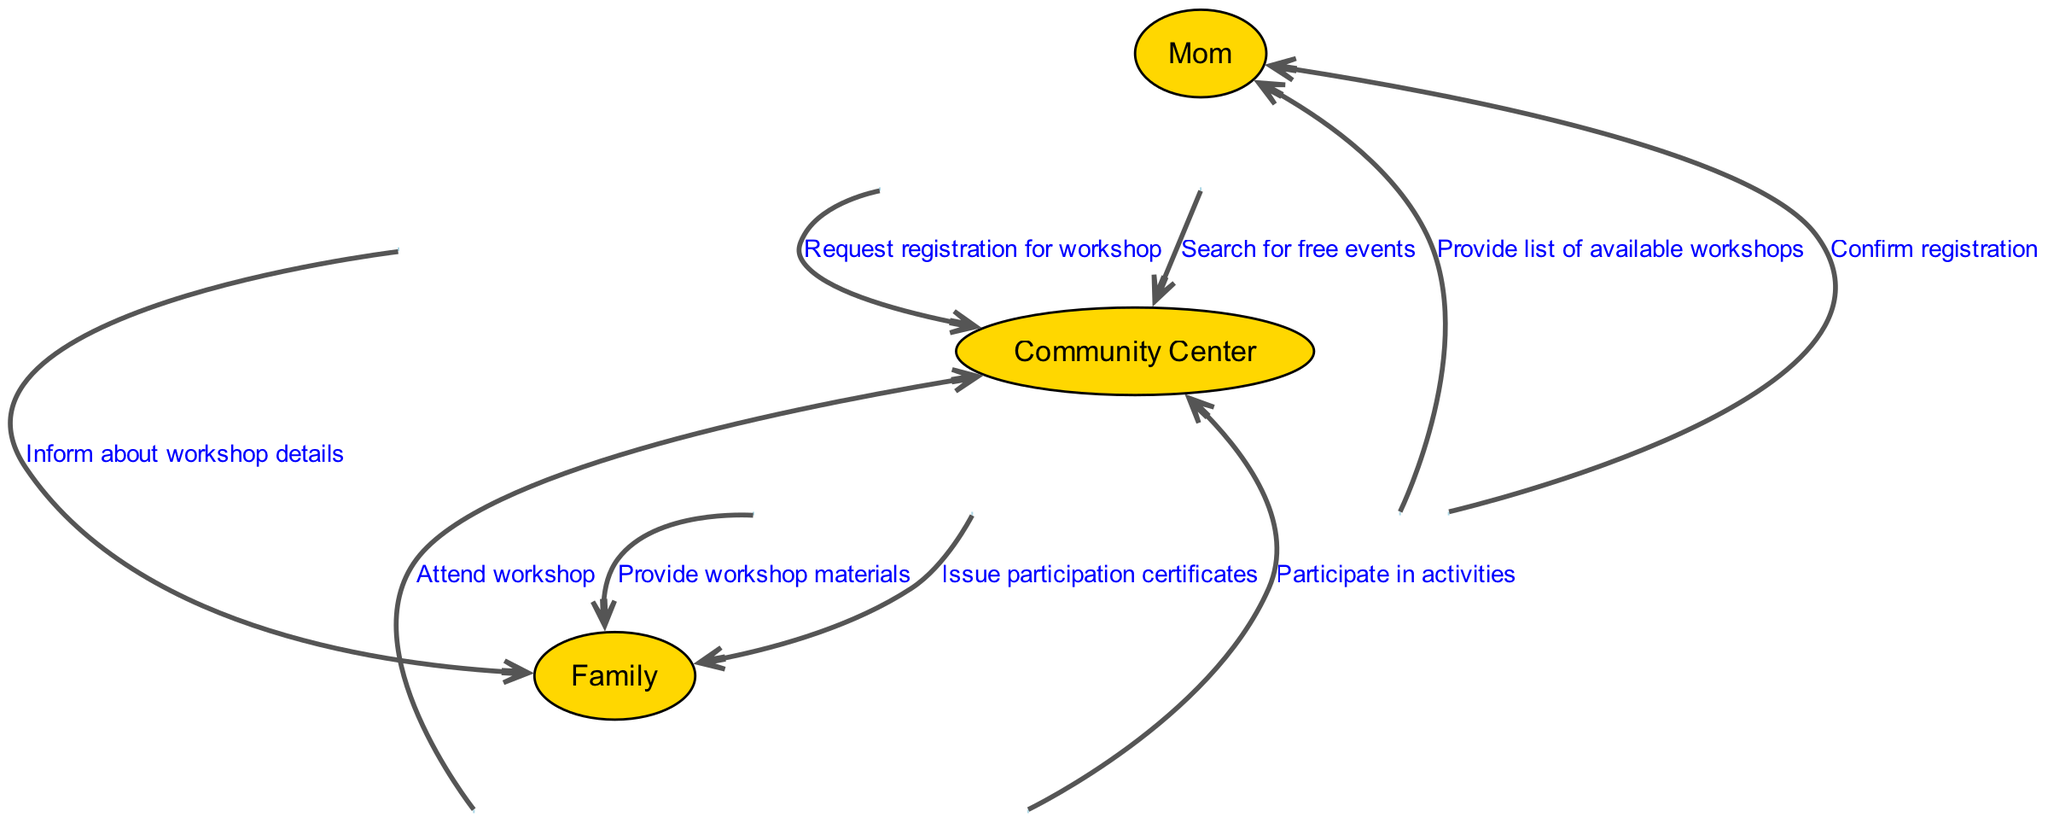What is the first action taken in the diagram? The first action is "Search for free events," which is initiated by the Mom to the Community Center. This first step is crucial as it kicks off the entire process of attending a workshop.
Answer: Search for free events How many actors are involved in the sequence? The diagram includes three actors: Mom, Community Center, and Family. Each actor plays a specific role, indicating their interaction throughout the event process.
Answer: 3 What message does the Community Center send to the Mom after the search? After Mom searches for free events, the Community Center provides a list of available workshops, which is an essential piece of information for Mom to continue with the process.
Answer: Provide list of available workshops Which actor receives the participation certificates? The Family receives the participation certificates at the end of the process, signaling their successful involvement in the community event. This action shows the recognition of their participation.
Answer: Family What is the final action completed in the diagram? The final action is the issuance of participation certificates by the Community Center to the Family. This indicates the end of the sequence for the workshop involvement.
Answer: Issue participation certificates What is the relationship between the Mom and the Family in this process? The relationship is that the Mom informs the Family about the workshop details, representing her role as the communicator within the process of attending the workshop.
Answer: Inform about workshop details How many total actions are represented in the sequence? The diagram features a total of seven distinct actions that describe the complete flow of activities from searching for an event to receiving certificates. Counting each action offers insight into the complexity of the sequence.
Answer: 7 What does the Family do immediately after attending the workshop? After attending the workshop, the Family participates in activities, which is a crucial step following their attendance that involves engagement with the community event.
Answer: Participate in activities What is the purpose of the message "Request registration for workshop"? This message signifies the intention of the Mom to secure a spot for the Family at the workshop. It is a necessary action to confirm their participation in the upcoming event.
Answer: Request registration for workshop 